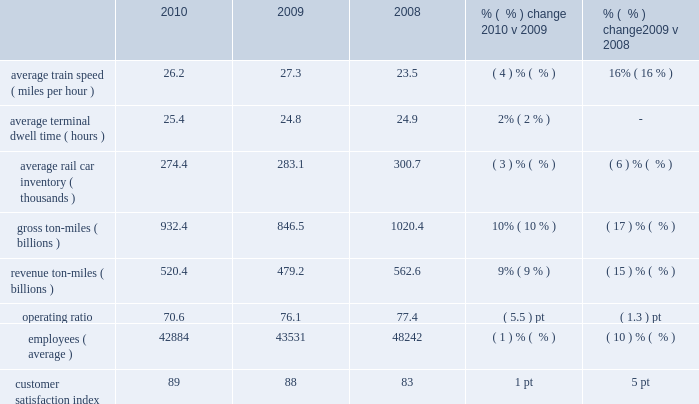Operating/performance statistics railroad performance measures reported to the aar , as well as other performance measures , are included in the table below : 2010 2009 2008 % (  % ) change 2010 v 2009 % (  % ) change 2009 v 2008 .
Average train speed 2013 average train speed is calculated by dividing train miles by hours operated on our main lines between terminals .
Maintenance activities and weather disruptions , combined with higher volume levels , led to a 4% ( 4 % ) decrease in average train speed in 2010 compared to a record set in 2009 .
Overall , we continued operating a fluid and efficient network during the year .
Lower volume levels , ongoing network management initiatives , and productivity improvements contributed to a 16% ( 16 % ) improvement in average train speed in 2009 compared to 2008 .
Average terminal dwell time 2013 average terminal dwell time is the average time that a rail car spends at our terminals .
Lower average terminal dwell time improves asset utilization and service .
Average terminal dwell time increased 2% ( 2 % ) in 2010 compared to 2009 , driven in part by our network plan to increase the length of numerous trains to improve overall efficiency , which resulted in higher terminal dwell time for some cars .
Average terminal dwell time improved slightly in 2009 compared to 2008 due to lower volume levels combined with initiatives to expedite delivering rail cars to our interchange partners and customers .
Average rail car inventory 2013 average rail car inventory is the daily average number of rail cars on our lines , including rail cars in storage .
Lower average rail car inventory reduces congestion in our yards and sidings , which increases train speed , reduces average terminal dwell time , and improves rail car utilization .
Average rail car inventory decreased 3% ( 3 % ) in 2010 compared to 2009 , while we handled 13% ( 13 % ) increases in carloads during the period compared to 2009 .
We maintained more freight cars off-line and retired a number of old freight cars , which drove the decreases .
Average rail car inventory decreased 6% ( 6 % ) in 2009 compared to 2008 driven by a 16% ( 16 % ) decrease in volume .
In addition , as carloads decreased , we stored more freight cars off-line .
Gross and revenue ton-miles 2013 gross ton-miles are calculated by multiplying the weight of loaded and empty freight cars by the number of miles hauled .
Revenue ton-miles are calculated by multiplying the weight of freight by the number of tariff miles .
Gross and revenue-ton-miles increased 10% ( 10 % ) and 9% ( 9 % ) in 2010 compared to 2009 due to a 13% ( 13 % ) increase in carloads .
Commodity mix changes ( notably automotive shipments ) drove the variance in year-over-year growth between gross ton-miles , revenue ton-miles and carloads .
Gross and revenue ton-miles decreased 17% ( 17 % ) and 15% ( 15 % ) in 2009 compared to 2008 due to a 16% ( 16 % ) decrease in carloads .
Commodity mix changes ( notably automotive shipments , which were 30% ( 30 % ) lower in 2009 versus 2008 ) drove the difference in declines between gross ton-miles and revenue ton- miles .
Operating ratio 2013 operating ratio is defined as our operating expenses as a percentage of operating revenue .
Our operating ratio improved 5.5 points to 70.6% ( 70.6 % ) in 2010 and 1.3 points to 76.1% ( 76.1 % ) in 2009 .
Efficiently leveraging volume increases , core pricing gains , and productivity initiatives drove the improvement in 2010 and more than offset the impact of higher fuel prices during the year .
Core pricing gains , lower fuel prices , network management initiatives , and improved productivity drove the improvement in 2009 and more than offset the 16% ( 16 % ) volume decline .
Employees 2013 employee levels were down 1% ( 1 % ) in 2010 compared to 2009 despite a 13% ( 13 % ) increase in volume levels .
We leveraged the additional volumes through network efficiencies and other productivity initiatives .
In addition , we successfully managed the growth of our full-time-equivalent train and engine force levels at a rate less than half of our carload growth in 2010 .
All other operating functions and .
What is the percentage increase from 2008 customer satisfaction index to the 2010 customer satisfaction index? 
Computations: ((89 - 83) / 83)
Answer: 0.07229. 